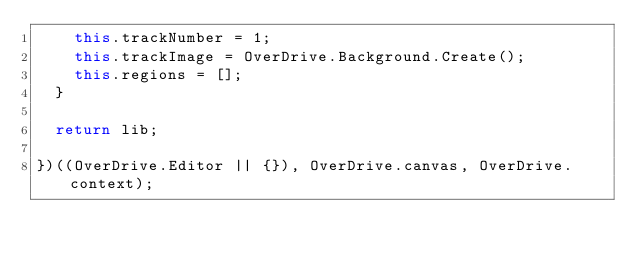<code> <loc_0><loc_0><loc_500><loc_500><_JavaScript_>    this.trackNumber = 1;
    this.trackImage = OverDrive.Background.Create();
    this.regions = [];
  }

  return lib;
  
})((OverDrive.Editor || {}), OverDrive.canvas, OverDrive.context);
</code> 